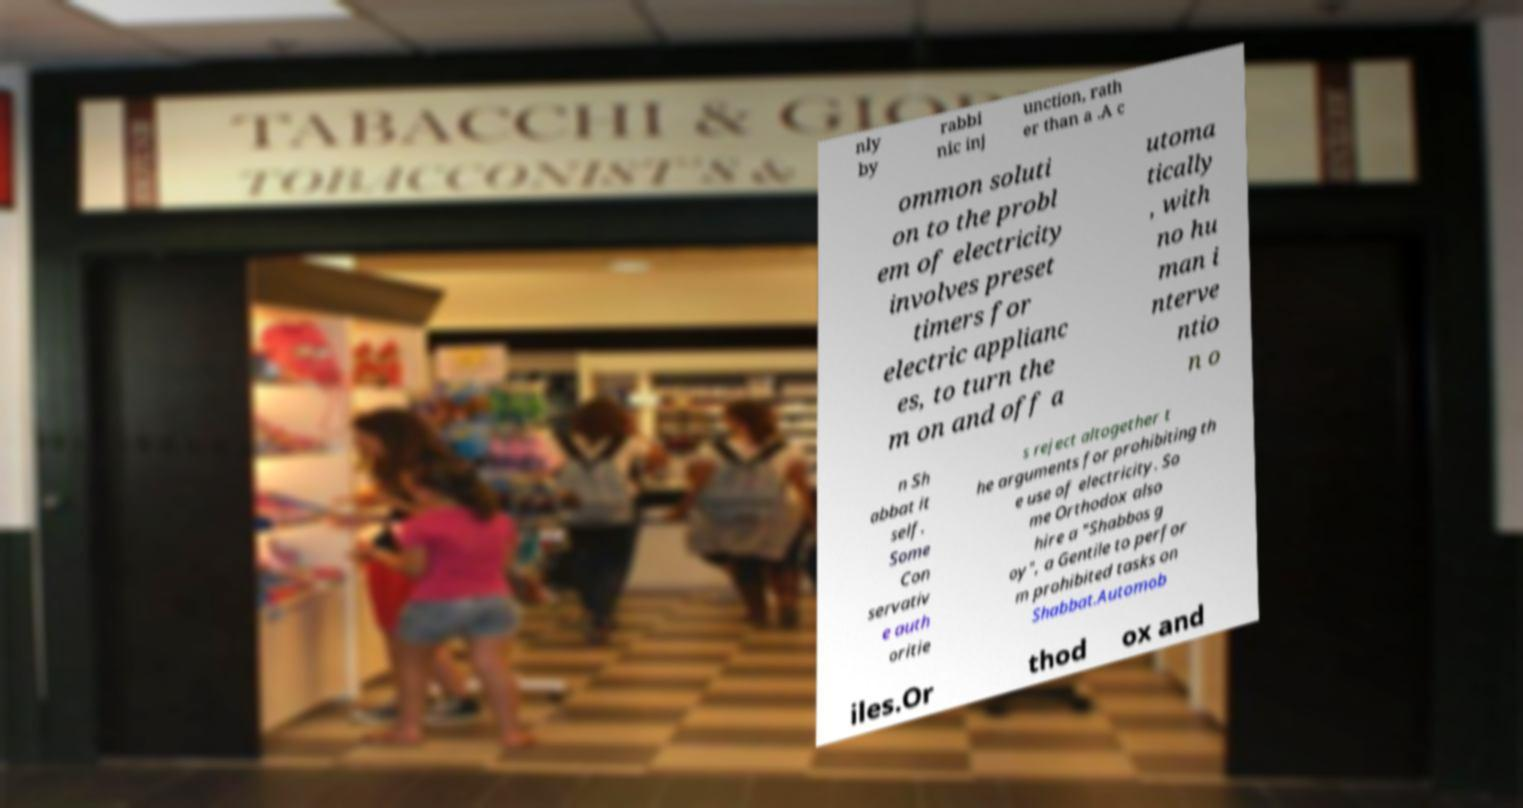What messages or text are displayed in this image? I need them in a readable, typed format. nly by rabbi nic inj unction, rath er than a .A c ommon soluti on to the probl em of electricity involves preset timers for electric applianc es, to turn the m on and off a utoma tically , with no hu man i nterve ntio n o n Sh abbat it self. Some Con servativ e auth oritie s reject altogether t he arguments for prohibiting th e use of electricity. So me Orthodox also hire a "Shabbos g oy", a Gentile to perfor m prohibited tasks on Shabbat.Automob iles.Or thod ox and 